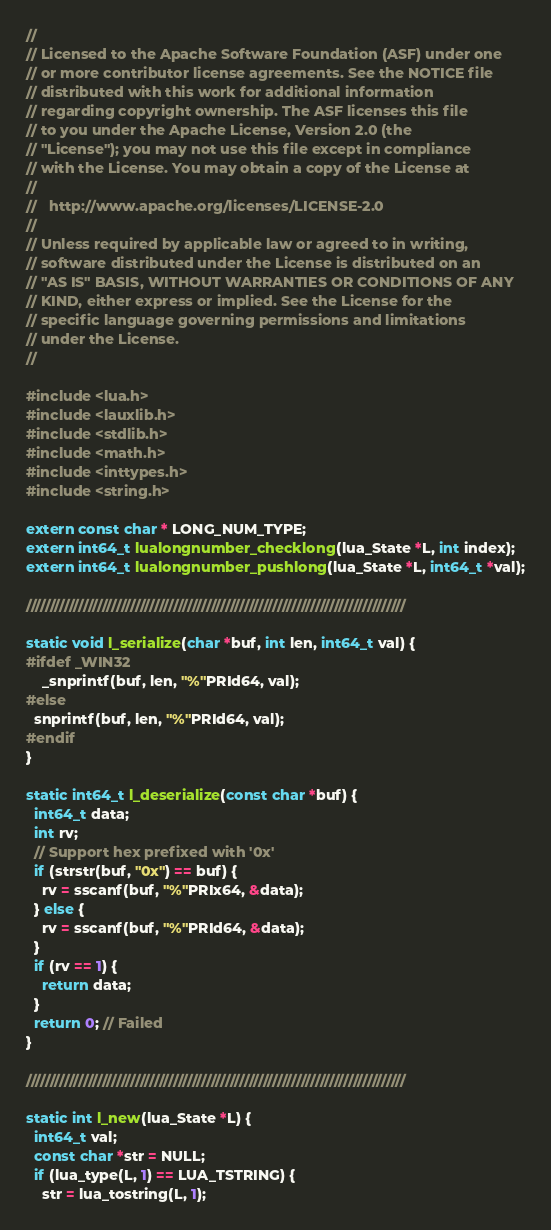<code> <loc_0><loc_0><loc_500><loc_500><_C_>//
// Licensed to the Apache Software Foundation (ASF) under one
// or more contributor license agreements. See the NOTICE file
// distributed with this work for additional information
// regarding copyright ownership. The ASF licenses this file
// to you under the Apache License, Version 2.0 (the
// "License"); you may not use this file except in compliance
// with the License. You may obtain a copy of the License at
//
//   http://www.apache.org/licenses/LICENSE-2.0
//
// Unless required by applicable law or agreed to in writing,
// software distributed under the License is distributed on an
// "AS IS" BASIS, WITHOUT WARRANTIES OR CONDITIONS OF ANY
// KIND, either express or implied. See the License for the
// specific language governing permissions and limitations
// under the License.
//

#include <lua.h>
#include <lauxlib.h>
#include <stdlib.h>
#include <math.h>
#include <inttypes.h>
#include <string.h>

extern const char * LONG_NUM_TYPE;
extern int64_t lualongnumber_checklong(lua_State *L, int index);
extern int64_t lualongnumber_pushlong(lua_State *L, int64_t *val);

////////////////////////////////////////////////////////////////////////////////

static void l_serialize(char *buf, int len, int64_t val) {
#ifdef _WIN32
	_snprintf(buf, len, "%"PRId64, val);
#else
  snprintf(buf, len, "%"PRId64, val);
#endif 
}

static int64_t l_deserialize(const char *buf) {
  int64_t data;
  int rv;
  // Support hex prefixed with '0x'
  if (strstr(buf, "0x") == buf) {
    rv = sscanf(buf, "%"PRIx64, &data);
  } else {
    rv = sscanf(buf, "%"PRId64, &data);
  }
  if (rv == 1) {
    return data;
  }
  return 0; // Failed
}

////////////////////////////////////////////////////////////////////////////////

static int l_new(lua_State *L) {
  int64_t val;
  const char *str = NULL;
  if (lua_type(L, 1) == LUA_TSTRING) {
    str = lua_tostring(L, 1);</code> 